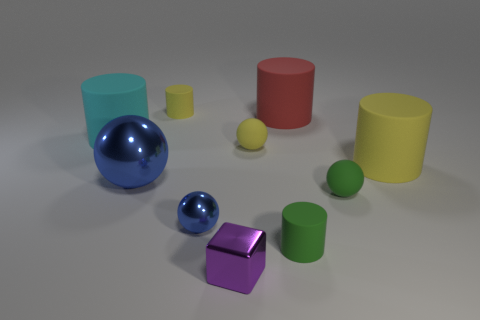Do the big metal thing and the small cylinder right of the tiny shiny cube have the same color?
Your answer should be compact. No. How many yellow cylinders are on the left side of the purple metallic thing?
Your response must be concise. 1. Are there fewer big yellow cylinders that are left of the small blue sphere than large shiny objects?
Make the answer very short. Yes. The large sphere is what color?
Provide a short and direct response. Blue. Is the color of the small matte sphere on the left side of the red cylinder the same as the small cube?
Give a very brief answer. No. There is another metal thing that is the same shape as the tiny blue thing; what is its color?
Keep it short and to the point. Blue. What number of large objects are yellow matte objects or purple shiny objects?
Ensure brevity in your answer.  1. What is the size of the metal object on the right side of the small blue metal sphere?
Keep it short and to the point. Small. Is there a object of the same color as the big sphere?
Give a very brief answer. Yes. Do the large shiny object and the small shiny cube have the same color?
Provide a succinct answer. No. 